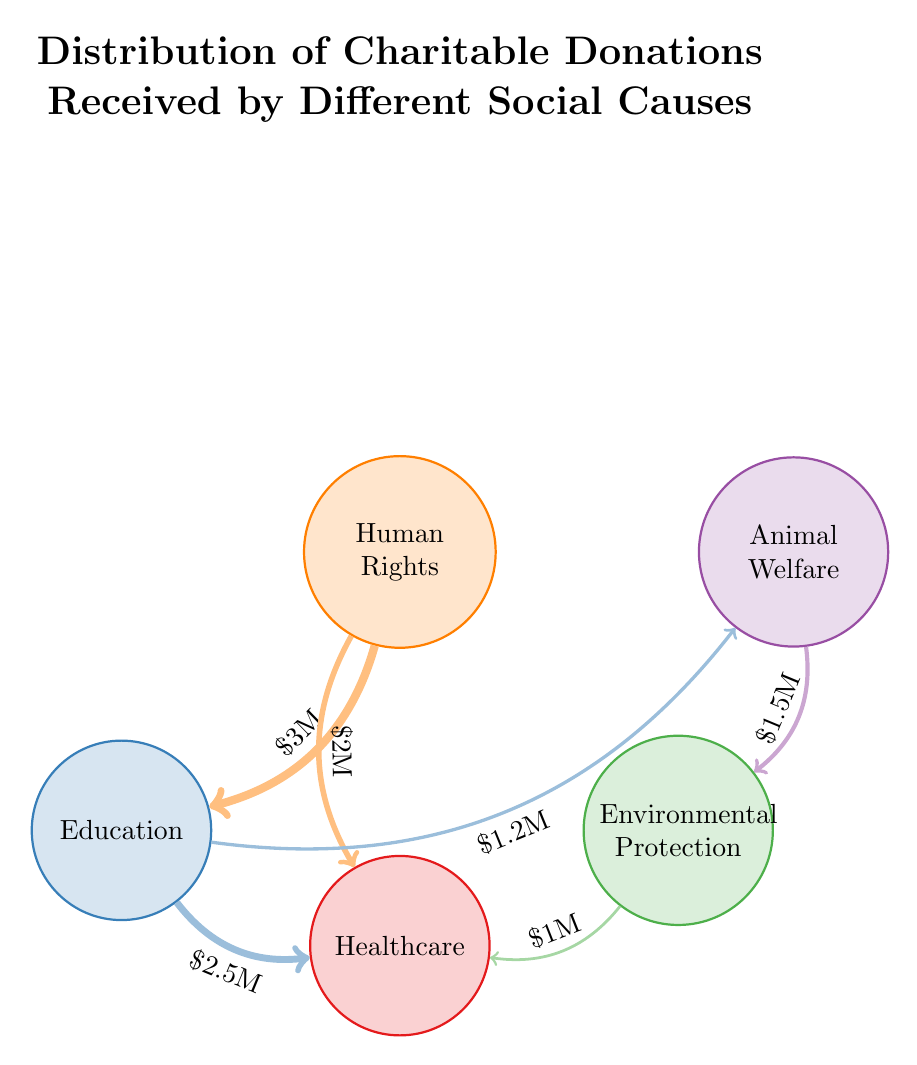What is the total amount of donations received by Human Rights? By examining the connections from the Human Rights node, we see two outgoing links: one to Education worth 3 million and one to Healthcare worth 2 million. Adding these values together gives 3 million + 2 million = 5 million.
Answer: 5 million Which cause received the least amount in donations? Looking at the connections, the only outgoing donation that is less than others is Environmental Protection, which received 1 million from Healthcare. This indicates it has the smallest donation value compared to the others.
Answer: 1 million How much did Education receive from Healthcare? The diagram shows a directed link from Education to Healthcare with a value of 2.5 million. Hence, this is the amount Education received from Healthcare.
Answer: 2.5 million What is the total amount of donations received by Healthcare? Healthcare has three links: 2 million from Human Rights, 2.5 million from Education, and 1 million from Environmental Protection. Adding these values gives 2 million + 2.5 million + 1 million = 5.5 million.
Answer: 5.5 million How many total unique social causes are represented in the diagram? The diagram includes five distinct nodes: Human Rights, Animal Welfare, Environmental Protection, Education, and Healthcare. Counting these gives a total of 5 unique causes.
Answer: 5 Which two social causes are closely connected by the highest donation amount? By reviewing the links, the largest single donation is from Education to Healthcare, which is 2.5 million. Thus, these two causes are the most closely connected by the largest donation.
Answer: Education, Healthcare What is the total value of donations flowing into Education? Education receives 3 million from Human Rights and 1.2 million from Animal Welfare, thus the total inflow is 3 million + 1.2 million = 4.2 million.
Answer: 4.2 million How many outgoing links does Animal Welfare have? Analyzing the Animal Welfare node shows one outgoing link to Environmental Protection worth 1.5 million and one to Education worth 1.2 million. Hence, it has a total of 2 outgoing links.
Answer: 2 From which cause does Environmental Protection receive donations, and how much? Environmental Protection has an incoming link from Animal Welfare which amounts to 1.5 million. Therefore, it receives donations only from that cause at that value.
Answer: Animal Welfare, 1.5 million Which cause has the largest incoming donation amount? Healthcare has three incoming donations: 2 million from Human Rights, 2.5 million from Education, and 1 million from Environmental Protection. Summing these gives 5.5 million, making it the cause with the largest incoming donations.
Answer: Healthcare 